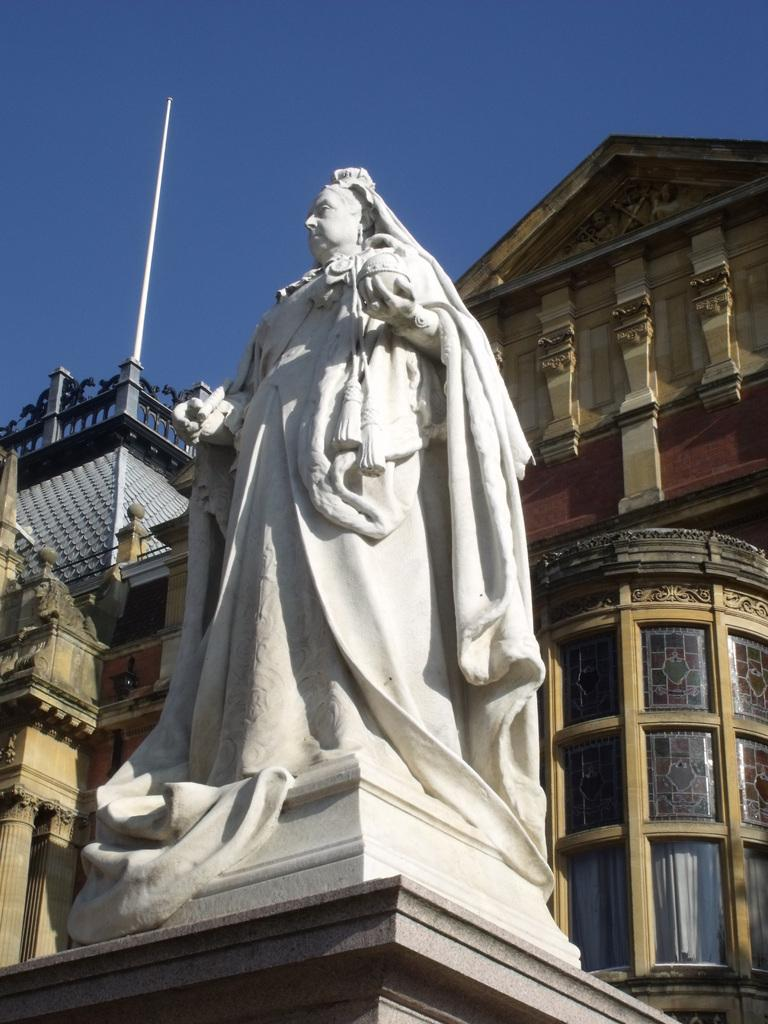What is the main subject in the middle of the image? There is a statue in the middle of the image. What can be seen in the background of the image? There are buildings in the background of the image. What type of hair can be seen on the statue in the image? There is no hair present on the statue in the image, as statues are typically made of materials like stone or metal and do not have hair. 